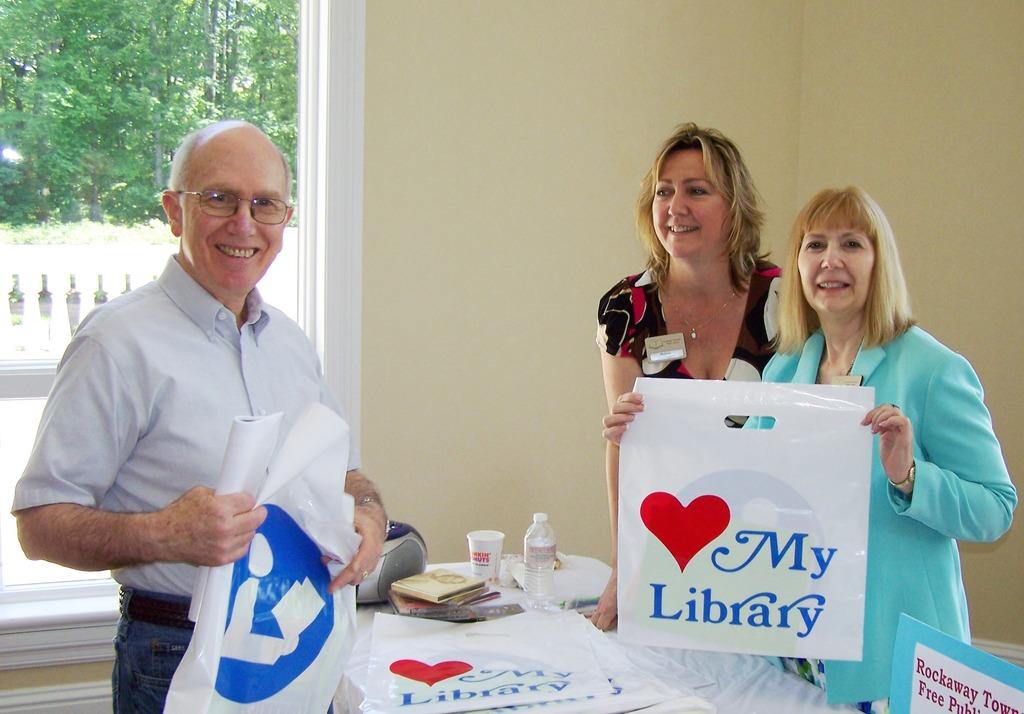What do the bags say people love?
Ensure brevity in your answer.  My library. 